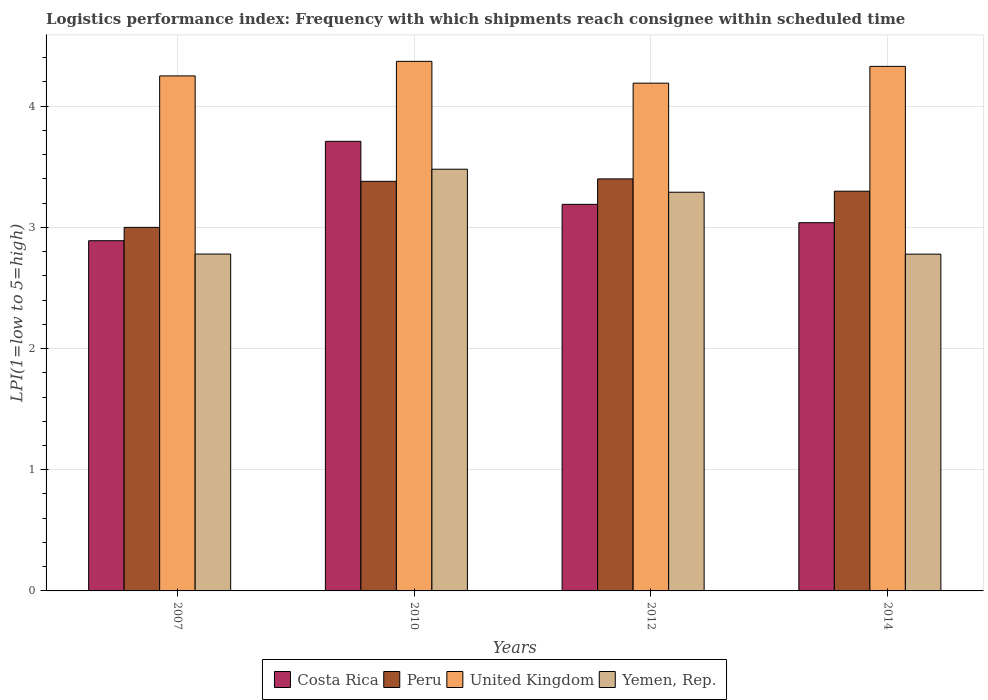Are the number of bars on each tick of the X-axis equal?
Give a very brief answer. Yes. What is the label of the 2nd group of bars from the left?
Ensure brevity in your answer.  2010. In how many cases, is the number of bars for a given year not equal to the number of legend labels?
Ensure brevity in your answer.  0. What is the logistics performance index in Yemen, Rep. in 2012?
Provide a succinct answer. 3.29. Across all years, what is the minimum logistics performance index in Yemen, Rep.?
Your answer should be very brief. 2.78. In which year was the logistics performance index in Peru maximum?
Give a very brief answer. 2012. In which year was the logistics performance index in Costa Rica minimum?
Your response must be concise. 2007. What is the total logistics performance index in United Kingdom in the graph?
Ensure brevity in your answer.  17.14. What is the difference between the logistics performance index in Peru in 2012 and that in 2014?
Your response must be concise. 0.1. What is the difference between the logistics performance index in Costa Rica in 2014 and the logistics performance index in Yemen, Rep. in 2012?
Your answer should be compact. -0.25. What is the average logistics performance index in United Kingdom per year?
Your answer should be compact. 4.28. In the year 2012, what is the difference between the logistics performance index in United Kingdom and logistics performance index in Peru?
Offer a very short reply. 0.79. In how many years, is the logistics performance index in Yemen, Rep. greater than 3.6?
Your answer should be very brief. 0. What is the ratio of the logistics performance index in Yemen, Rep. in 2007 to that in 2014?
Ensure brevity in your answer.  1. Is the logistics performance index in Costa Rica in 2012 less than that in 2014?
Give a very brief answer. No. What is the difference between the highest and the second highest logistics performance index in Yemen, Rep.?
Keep it short and to the point. 0.19. What is the difference between the highest and the lowest logistics performance index in Costa Rica?
Your answer should be very brief. 0.82. Is the sum of the logistics performance index in Yemen, Rep. in 2007 and 2010 greater than the maximum logistics performance index in Costa Rica across all years?
Your response must be concise. Yes. Is it the case that in every year, the sum of the logistics performance index in Costa Rica and logistics performance index in United Kingdom is greater than the sum of logistics performance index in Peru and logistics performance index in Yemen, Rep.?
Offer a terse response. Yes. What does the 4th bar from the left in 2012 represents?
Ensure brevity in your answer.  Yemen, Rep. What does the 1st bar from the right in 2010 represents?
Make the answer very short. Yemen, Rep. Is it the case that in every year, the sum of the logistics performance index in Costa Rica and logistics performance index in Peru is greater than the logistics performance index in United Kingdom?
Your answer should be very brief. Yes. Are all the bars in the graph horizontal?
Make the answer very short. No. What is the difference between two consecutive major ticks on the Y-axis?
Give a very brief answer. 1. Does the graph contain any zero values?
Provide a short and direct response. No. Where does the legend appear in the graph?
Give a very brief answer. Bottom center. What is the title of the graph?
Provide a short and direct response. Logistics performance index: Frequency with which shipments reach consignee within scheduled time. What is the label or title of the Y-axis?
Offer a terse response. LPI(1=low to 5=high). What is the LPI(1=low to 5=high) of Costa Rica in 2007?
Offer a very short reply. 2.89. What is the LPI(1=low to 5=high) in Peru in 2007?
Your answer should be very brief. 3. What is the LPI(1=low to 5=high) of United Kingdom in 2007?
Offer a very short reply. 4.25. What is the LPI(1=low to 5=high) in Yemen, Rep. in 2007?
Your answer should be compact. 2.78. What is the LPI(1=low to 5=high) in Costa Rica in 2010?
Give a very brief answer. 3.71. What is the LPI(1=low to 5=high) of Peru in 2010?
Your answer should be very brief. 3.38. What is the LPI(1=low to 5=high) in United Kingdom in 2010?
Your answer should be very brief. 4.37. What is the LPI(1=low to 5=high) of Yemen, Rep. in 2010?
Provide a succinct answer. 3.48. What is the LPI(1=low to 5=high) of Costa Rica in 2012?
Ensure brevity in your answer.  3.19. What is the LPI(1=low to 5=high) of Peru in 2012?
Give a very brief answer. 3.4. What is the LPI(1=low to 5=high) of United Kingdom in 2012?
Keep it short and to the point. 4.19. What is the LPI(1=low to 5=high) of Yemen, Rep. in 2012?
Provide a short and direct response. 3.29. What is the LPI(1=low to 5=high) of Costa Rica in 2014?
Your answer should be very brief. 3.04. What is the LPI(1=low to 5=high) of Peru in 2014?
Your response must be concise. 3.3. What is the LPI(1=low to 5=high) in United Kingdom in 2014?
Give a very brief answer. 4.33. What is the LPI(1=low to 5=high) in Yemen, Rep. in 2014?
Offer a terse response. 2.78. Across all years, what is the maximum LPI(1=low to 5=high) in Costa Rica?
Offer a very short reply. 3.71. Across all years, what is the maximum LPI(1=low to 5=high) of United Kingdom?
Keep it short and to the point. 4.37. Across all years, what is the maximum LPI(1=low to 5=high) in Yemen, Rep.?
Offer a terse response. 3.48. Across all years, what is the minimum LPI(1=low to 5=high) in Costa Rica?
Ensure brevity in your answer.  2.89. Across all years, what is the minimum LPI(1=low to 5=high) of Peru?
Your response must be concise. 3. Across all years, what is the minimum LPI(1=low to 5=high) of United Kingdom?
Give a very brief answer. 4.19. Across all years, what is the minimum LPI(1=low to 5=high) of Yemen, Rep.?
Make the answer very short. 2.78. What is the total LPI(1=low to 5=high) of Costa Rica in the graph?
Offer a very short reply. 12.83. What is the total LPI(1=low to 5=high) in Peru in the graph?
Ensure brevity in your answer.  13.08. What is the total LPI(1=low to 5=high) in United Kingdom in the graph?
Give a very brief answer. 17.14. What is the total LPI(1=low to 5=high) in Yemen, Rep. in the graph?
Your answer should be very brief. 12.33. What is the difference between the LPI(1=low to 5=high) of Costa Rica in 2007 and that in 2010?
Offer a terse response. -0.82. What is the difference between the LPI(1=low to 5=high) in Peru in 2007 and that in 2010?
Offer a very short reply. -0.38. What is the difference between the LPI(1=low to 5=high) of United Kingdom in 2007 and that in 2010?
Your answer should be compact. -0.12. What is the difference between the LPI(1=low to 5=high) of Costa Rica in 2007 and that in 2012?
Your response must be concise. -0.3. What is the difference between the LPI(1=low to 5=high) of United Kingdom in 2007 and that in 2012?
Give a very brief answer. 0.06. What is the difference between the LPI(1=low to 5=high) in Yemen, Rep. in 2007 and that in 2012?
Provide a short and direct response. -0.51. What is the difference between the LPI(1=low to 5=high) in Costa Rica in 2007 and that in 2014?
Your response must be concise. -0.15. What is the difference between the LPI(1=low to 5=high) of Peru in 2007 and that in 2014?
Provide a short and direct response. -0.3. What is the difference between the LPI(1=low to 5=high) of United Kingdom in 2007 and that in 2014?
Offer a very short reply. -0.08. What is the difference between the LPI(1=low to 5=high) of Yemen, Rep. in 2007 and that in 2014?
Provide a short and direct response. 0. What is the difference between the LPI(1=low to 5=high) in Costa Rica in 2010 and that in 2012?
Your response must be concise. 0.52. What is the difference between the LPI(1=low to 5=high) in Peru in 2010 and that in 2012?
Your answer should be very brief. -0.02. What is the difference between the LPI(1=low to 5=high) of United Kingdom in 2010 and that in 2012?
Make the answer very short. 0.18. What is the difference between the LPI(1=low to 5=high) in Yemen, Rep. in 2010 and that in 2012?
Your response must be concise. 0.19. What is the difference between the LPI(1=low to 5=high) of Costa Rica in 2010 and that in 2014?
Provide a short and direct response. 0.67. What is the difference between the LPI(1=low to 5=high) of Peru in 2010 and that in 2014?
Keep it short and to the point. 0.08. What is the difference between the LPI(1=low to 5=high) in United Kingdom in 2010 and that in 2014?
Give a very brief answer. 0.04. What is the difference between the LPI(1=low to 5=high) of Yemen, Rep. in 2010 and that in 2014?
Keep it short and to the point. 0.7. What is the difference between the LPI(1=low to 5=high) in Costa Rica in 2012 and that in 2014?
Offer a terse response. 0.15. What is the difference between the LPI(1=low to 5=high) in Peru in 2012 and that in 2014?
Keep it short and to the point. 0.1. What is the difference between the LPI(1=low to 5=high) in United Kingdom in 2012 and that in 2014?
Your answer should be compact. -0.14. What is the difference between the LPI(1=low to 5=high) in Yemen, Rep. in 2012 and that in 2014?
Your answer should be compact. 0.51. What is the difference between the LPI(1=low to 5=high) of Costa Rica in 2007 and the LPI(1=low to 5=high) of Peru in 2010?
Ensure brevity in your answer.  -0.49. What is the difference between the LPI(1=low to 5=high) of Costa Rica in 2007 and the LPI(1=low to 5=high) of United Kingdom in 2010?
Ensure brevity in your answer.  -1.48. What is the difference between the LPI(1=low to 5=high) in Costa Rica in 2007 and the LPI(1=low to 5=high) in Yemen, Rep. in 2010?
Give a very brief answer. -0.59. What is the difference between the LPI(1=low to 5=high) of Peru in 2007 and the LPI(1=low to 5=high) of United Kingdom in 2010?
Keep it short and to the point. -1.37. What is the difference between the LPI(1=low to 5=high) of Peru in 2007 and the LPI(1=low to 5=high) of Yemen, Rep. in 2010?
Your answer should be very brief. -0.48. What is the difference between the LPI(1=low to 5=high) of United Kingdom in 2007 and the LPI(1=low to 5=high) of Yemen, Rep. in 2010?
Your response must be concise. 0.77. What is the difference between the LPI(1=low to 5=high) in Costa Rica in 2007 and the LPI(1=low to 5=high) in Peru in 2012?
Ensure brevity in your answer.  -0.51. What is the difference between the LPI(1=low to 5=high) in Costa Rica in 2007 and the LPI(1=low to 5=high) in United Kingdom in 2012?
Ensure brevity in your answer.  -1.3. What is the difference between the LPI(1=low to 5=high) in Peru in 2007 and the LPI(1=low to 5=high) in United Kingdom in 2012?
Provide a short and direct response. -1.19. What is the difference between the LPI(1=low to 5=high) of Peru in 2007 and the LPI(1=low to 5=high) of Yemen, Rep. in 2012?
Make the answer very short. -0.29. What is the difference between the LPI(1=low to 5=high) of United Kingdom in 2007 and the LPI(1=low to 5=high) of Yemen, Rep. in 2012?
Keep it short and to the point. 0.96. What is the difference between the LPI(1=low to 5=high) of Costa Rica in 2007 and the LPI(1=low to 5=high) of Peru in 2014?
Make the answer very short. -0.41. What is the difference between the LPI(1=low to 5=high) of Costa Rica in 2007 and the LPI(1=low to 5=high) of United Kingdom in 2014?
Provide a short and direct response. -1.44. What is the difference between the LPI(1=low to 5=high) in Costa Rica in 2007 and the LPI(1=low to 5=high) in Yemen, Rep. in 2014?
Keep it short and to the point. 0.11. What is the difference between the LPI(1=low to 5=high) of Peru in 2007 and the LPI(1=low to 5=high) of United Kingdom in 2014?
Provide a succinct answer. -1.33. What is the difference between the LPI(1=low to 5=high) in Peru in 2007 and the LPI(1=low to 5=high) in Yemen, Rep. in 2014?
Offer a very short reply. 0.22. What is the difference between the LPI(1=low to 5=high) in United Kingdom in 2007 and the LPI(1=low to 5=high) in Yemen, Rep. in 2014?
Offer a very short reply. 1.47. What is the difference between the LPI(1=low to 5=high) in Costa Rica in 2010 and the LPI(1=low to 5=high) in Peru in 2012?
Ensure brevity in your answer.  0.31. What is the difference between the LPI(1=low to 5=high) of Costa Rica in 2010 and the LPI(1=low to 5=high) of United Kingdom in 2012?
Offer a terse response. -0.48. What is the difference between the LPI(1=low to 5=high) of Costa Rica in 2010 and the LPI(1=low to 5=high) of Yemen, Rep. in 2012?
Your answer should be very brief. 0.42. What is the difference between the LPI(1=low to 5=high) in Peru in 2010 and the LPI(1=low to 5=high) in United Kingdom in 2012?
Give a very brief answer. -0.81. What is the difference between the LPI(1=low to 5=high) in Peru in 2010 and the LPI(1=low to 5=high) in Yemen, Rep. in 2012?
Offer a very short reply. 0.09. What is the difference between the LPI(1=low to 5=high) of Costa Rica in 2010 and the LPI(1=low to 5=high) of Peru in 2014?
Provide a succinct answer. 0.41. What is the difference between the LPI(1=low to 5=high) in Costa Rica in 2010 and the LPI(1=low to 5=high) in United Kingdom in 2014?
Provide a succinct answer. -0.62. What is the difference between the LPI(1=low to 5=high) of Costa Rica in 2010 and the LPI(1=low to 5=high) of Yemen, Rep. in 2014?
Your answer should be very brief. 0.93. What is the difference between the LPI(1=low to 5=high) of Peru in 2010 and the LPI(1=low to 5=high) of United Kingdom in 2014?
Your answer should be compact. -0.95. What is the difference between the LPI(1=low to 5=high) in Peru in 2010 and the LPI(1=low to 5=high) in Yemen, Rep. in 2014?
Ensure brevity in your answer.  0.6. What is the difference between the LPI(1=low to 5=high) in United Kingdom in 2010 and the LPI(1=low to 5=high) in Yemen, Rep. in 2014?
Your response must be concise. 1.59. What is the difference between the LPI(1=low to 5=high) of Costa Rica in 2012 and the LPI(1=low to 5=high) of Peru in 2014?
Offer a very short reply. -0.11. What is the difference between the LPI(1=low to 5=high) of Costa Rica in 2012 and the LPI(1=low to 5=high) of United Kingdom in 2014?
Provide a succinct answer. -1.14. What is the difference between the LPI(1=low to 5=high) of Costa Rica in 2012 and the LPI(1=low to 5=high) of Yemen, Rep. in 2014?
Ensure brevity in your answer.  0.41. What is the difference between the LPI(1=low to 5=high) of Peru in 2012 and the LPI(1=low to 5=high) of United Kingdom in 2014?
Provide a succinct answer. -0.93. What is the difference between the LPI(1=low to 5=high) in Peru in 2012 and the LPI(1=low to 5=high) in Yemen, Rep. in 2014?
Offer a very short reply. 0.62. What is the difference between the LPI(1=low to 5=high) in United Kingdom in 2012 and the LPI(1=low to 5=high) in Yemen, Rep. in 2014?
Offer a very short reply. 1.41. What is the average LPI(1=low to 5=high) of Costa Rica per year?
Offer a terse response. 3.21. What is the average LPI(1=low to 5=high) in Peru per year?
Make the answer very short. 3.27. What is the average LPI(1=low to 5=high) in United Kingdom per year?
Ensure brevity in your answer.  4.28. What is the average LPI(1=low to 5=high) of Yemen, Rep. per year?
Make the answer very short. 3.08. In the year 2007, what is the difference between the LPI(1=low to 5=high) in Costa Rica and LPI(1=low to 5=high) in Peru?
Offer a very short reply. -0.11. In the year 2007, what is the difference between the LPI(1=low to 5=high) of Costa Rica and LPI(1=low to 5=high) of United Kingdom?
Offer a very short reply. -1.36. In the year 2007, what is the difference between the LPI(1=low to 5=high) of Costa Rica and LPI(1=low to 5=high) of Yemen, Rep.?
Keep it short and to the point. 0.11. In the year 2007, what is the difference between the LPI(1=low to 5=high) of Peru and LPI(1=low to 5=high) of United Kingdom?
Offer a very short reply. -1.25. In the year 2007, what is the difference between the LPI(1=low to 5=high) of Peru and LPI(1=low to 5=high) of Yemen, Rep.?
Provide a succinct answer. 0.22. In the year 2007, what is the difference between the LPI(1=low to 5=high) in United Kingdom and LPI(1=low to 5=high) in Yemen, Rep.?
Your response must be concise. 1.47. In the year 2010, what is the difference between the LPI(1=low to 5=high) in Costa Rica and LPI(1=low to 5=high) in Peru?
Make the answer very short. 0.33. In the year 2010, what is the difference between the LPI(1=low to 5=high) in Costa Rica and LPI(1=low to 5=high) in United Kingdom?
Offer a terse response. -0.66. In the year 2010, what is the difference between the LPI(1=low to 5=high) of Costa Rica and LPI(1=low to 5=high) of Yemen, Rep.?
Make the answer very short. 0.23. In the year 2010, what is the difference between the LPI(1=low to 5=high) in Peru and LPI(1=low to 5=high) in United Kingdom?
Offer a terse response. -0.99. In the year 2010, what is the difference between the LPI(1=low to 5=high) of United Kingdom and LPI(1=low to 5=high) of Yemen, Rep.?
Keep it short and to the point. 0.89. In the year 2012, what is the difference between the LPI(1=low to 5=high) of Costa Rica and LPI(1=low to 5=high) of Peru?
Offer a very short reply. -0.21. In the year 2012, what is the difference between the LPI(1=low to 5=high) in Costa Rica and LPI(1=low to 5=high) in United Kingdom?
Provide a succinct answer. -1. In the year 2012, what is the difference between the LPI(1=low to 5=high) in Peru and LPI(1=low to 5=high) in United Kingdom?
Offer a very short reply. -0.79. In the year 2012, what is the difference between the LPI(1=low to 5=high) of Peru and LPI(1=low to 5=high) of Yemen, Rep.?
Offer a very short reply. 0.11. In the year 2012, what is the difference between the LPI(1=low to 5=high) in United Kingdom and LPI(1=low to 5=high) in Yemen, Rep.?
Your response must be concise. 0.9. In the year 2014, what is the difference between the LPI(1=low to 5=high) of Costa Rica and LPI(1=low to 5=high) of Peru?
Your answer should be compact. -0.26. In the year 2014, what is the difference between the LPI(1=low to 5=high) of Costa Rica and LPI(1=low to 5=high) of United Kingdom?
Keep it short and to the point. -1.29. In the year 2014, what is the difference between the LPI(1=low to 5=high) in Costa Rica and LPI(1=low to 5=high) in Yemen, Rep.?
Keep it short and to the point. 0.26. In the year 2014, what is the difference between the LPI(1=low to 5=high) in Peru and LPI(1=low to 5=high) in United Kingdom?
Your answer should be very brief. -1.03. In the year 2014, what is the difference between the LPI(1=low to 5=high) in Peru and LPI(1=low to 5=high) in Yemen, Rep.?
Provide a short and direct response. 0.52. In the year 2014, what is the difference between the LPI(1=low to 5=high) of United Kingdom and LPI(1=low to 5=high) of Yemen, Rep.?
Your response must be concise. 1.55. What is the ratio of the LPI(1=low to 5=high) in Costa Rica in 2007 to that in 2010?
Offer a terse response. 0.78. What is the ratio of the LPI(1=low to 5=high) of Peru in 2007 to that in 2010?
Provide a short and direct response. 0.89. What is the ratio of the LPI(1=low to 5=high) of United Kingdom in 2007 to that in 2010?
Offer a terse response. 0.97. What is the ratio of the LPI(1=low to 5=high) of Yemen, Rep. in 2007 to that in 2010?
Your answer should be compact. 0.8. What is the ratio of the LPI(1=low to 5=high) in Costa Rica in 2007 to that in 2012?
Provide a succinct answer. 0.91. What is the ratio of the LPI(1=low to 5=high) in Peru in 2007 to that in 2012?
Provide a succinct answer. 0.88. What is the ratio of the LPI(1=low to 5=high) in United Kingdom in 2007 to that in 2012?
Ensure brevity in your answer.  1.01. What is the ratio of the LPI(1=low to 5=high) in Yemen, Rep. in 2007 to that in 2012?
Give a very brief answer. 0.84. What is the ratio of the LPI(1=low to 5=high) in Costa Rica in 2007 to that in 2014?
Offer a very short reply. 0.95. What is the ratio of the LPI(1=low to 5=high) of Peru in 2007 to that in 2014?
Provide a succinct answer. 0.91. What is the ratio of the LPI(1=low to 5=high) of United Kingdom in 2007 to that in 2014?
Give a very brief answer. 0.98. What is the ratio of the LPI(1=low to 5=high) of Yemen, Rep. in 2007 to that in 2014?
Give a very brief answer. 1. What is the ratio of the LPI(1=low to 5=high) in Costa Rica in 2010 to that in 2012?
Keep it short and to the point. 1.16. What is the ratio of the LPI(1=low to 5=high) in United Kingdom in 2010 to that in 2012?
Keep it short and to the point. 1.04. What is the ratio of the LPI(1=low to 5=high) in Yemen, Rep. in 2010 to that in 2012?
Provide a short and direct response. 1.06. What is the ratio of the LPI(1=low to 5=high) in Costa Rica in 2010 to that in 2014?
Ensure brevity in your answer.  1.22. What is the ratio of the LPI(1=low to 5=high) in Peru in 2010 to that in 2014?
Keep it short and to the point. 1.02. What is the ratio of the LPI(1=low to 5=high) in United Kingdom in 2010 to that in 2014?
Your response must be concise. 1.01. What is the ratio of the LPI(1=low to 5=high) in Yemen, Rep. in 2010 to that in 2014?
Provide a short and direct response. 1.25. What is the ratio of the LPI(1=low to 5=high) in Costa Rica in 2012 to that in 2014?
Ensure brevity in your answer.  1.05. What is the ratio of the LPI(1=low to 5=high) of Peru in 2012 to that in 2014?
Give a very brief answer. 1.03. What is the ratio of the LPI(1=low to 5=high) of United Kingdom in 2012 to that in 2014?
Your response must be concise. 0.97. What is the ratio of the LPI(1=low to 5=high) in Yemen, Rep. in 2012 to that in 2014?
Your answer should be compact. 1.18. What is the difference between the highest and the second highest LPI(1=low to 5=high) in Costa Rica?
Your answer should be compact. 0.52. What is the difference between the highest and the second highest LPI(1=low to 5=high) of United Kingdom?
Your answer should be compact. 0.04. What is the difference between the highest and the second highest LPI(1=low to 5=high) of Yemen, Rep.?
Offer a terse response. 0.19. What is the difference between the highest and the lowest LPI(1=low to 5=high) in Costa Rica?
Offer a very short reply. 0.82. What is the difference between the highest and the lowest LPI(1=low to 5=high) in United Kingdom?
Offer a very short reply. 0.18. What is the difference between the highest and the lowest LPI(1=low to 5=high) of Yemen, Rep.?
Keep it short and to the point. 0.7. 